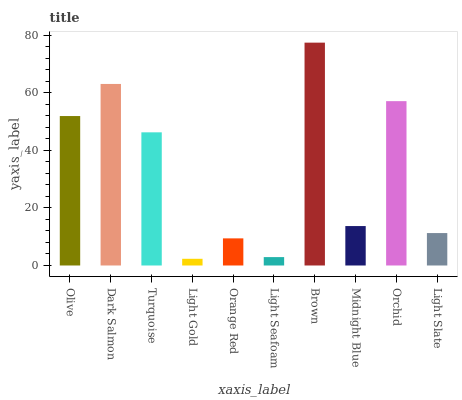Is Light Gold the minimum?
Answer yes or no. Yes. Is Brown the maximum?
Answer yes or no. Yes. Is Dark Salmon the minimum?
Answer yes or no. No. Is Dark Salmon the maximum?
Answer yes or no. No. Is Dark Salmon greater than Olive?
Answer yes or no. Yes. Is Olive less than Dark Salmon?
Answer yes or no. Yes. Is Olive greater than Dark Salmon?
Answer yes or no. No. Is Dark Salmon less than Olive?
Answer yes or no. No. Is Turquoise the high median?
Answer yes or no. Yes. Is Midnight Blue the low median?
Answer yes or no. Yes. Is Orchid the high median?
Answer yes or no. No. Is Dark Salmon the low median?
Answer yes or no. No. 